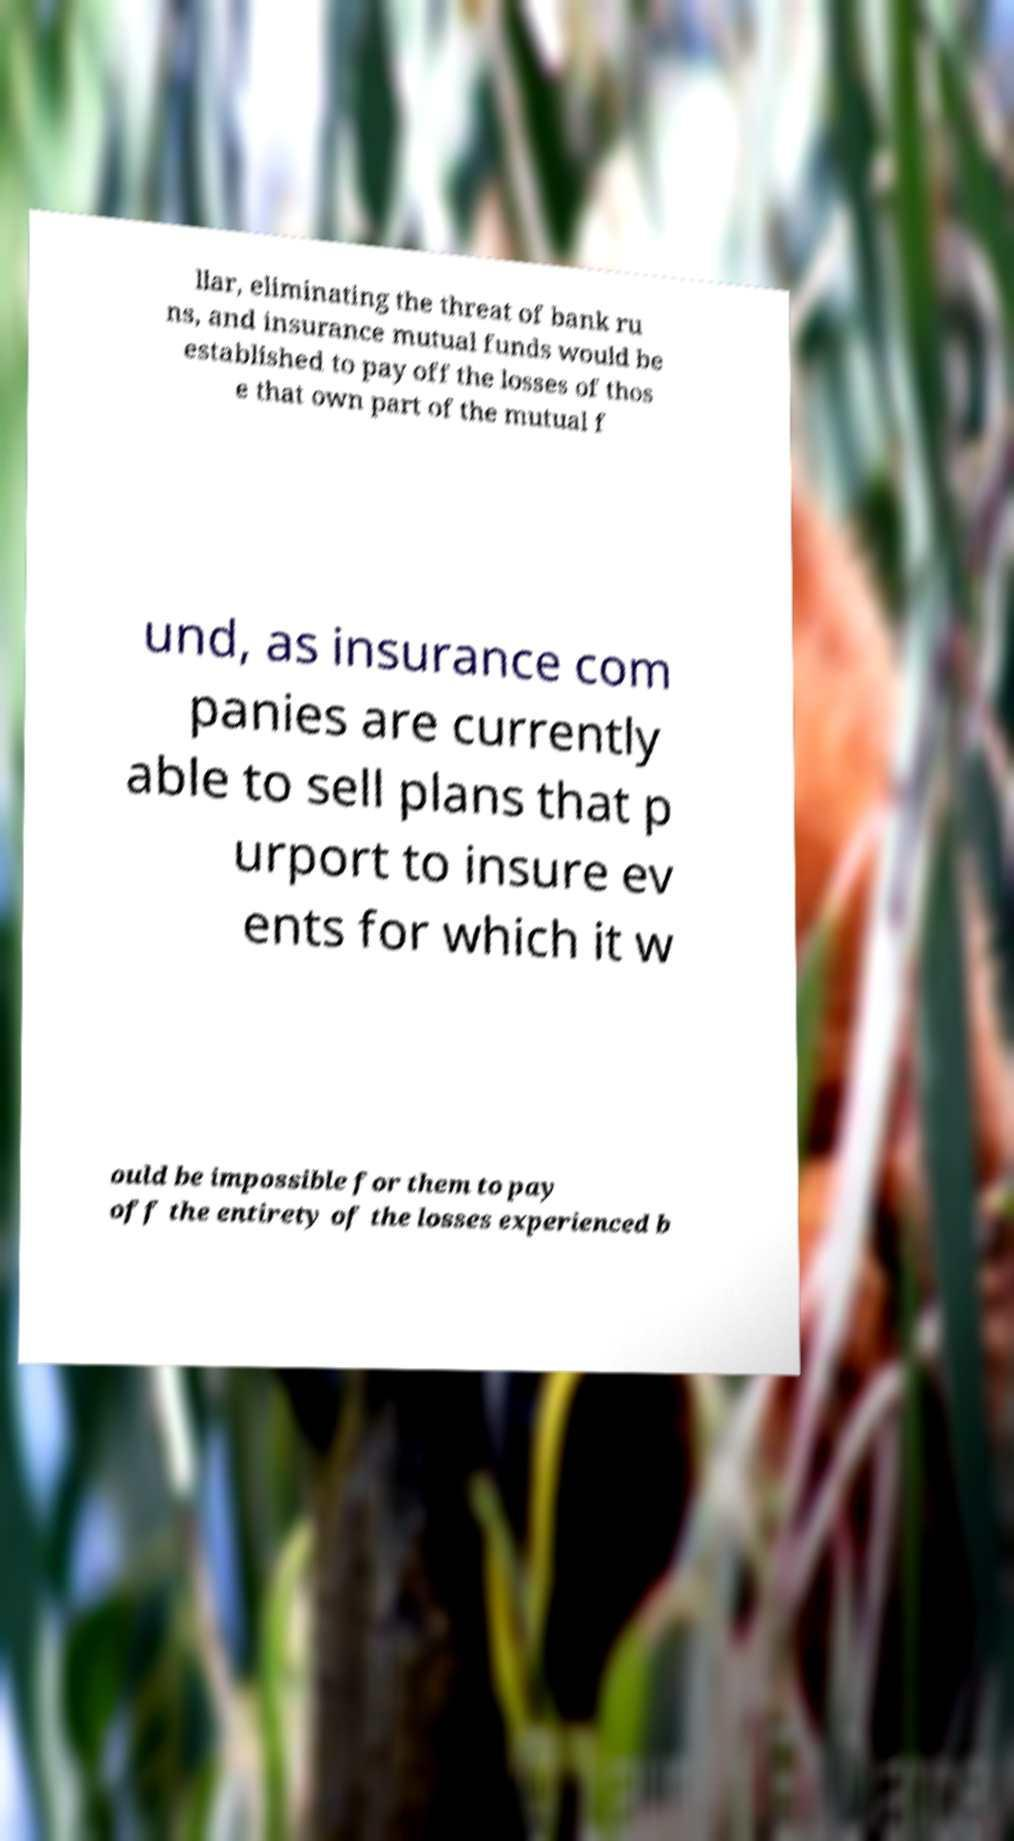I need the written content from this picture converted into text. Can you do that? llar, eliminating the threat of bank ru ns, and insurance mutual funds would be established to pay off the losses of thos e that own part of the mutual f und, as insurance com panies are currently able to sell plans that p urport to insure ev ents for which it w ould be impossible for them to pay off the entirety of the losses experienced b 